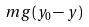Convert formula to latex. <formula><loc_0><loc_0><loc_500><loc_500>m g ( y _ { 0 } - y )</formula> 